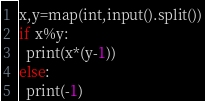<code> <loc_0><loc_0><loc_500><loc_500><_Python_>x,y=map(int,input().split())
if x%y:
  print(x*(y-1))
else:
  print(-1)</code> 